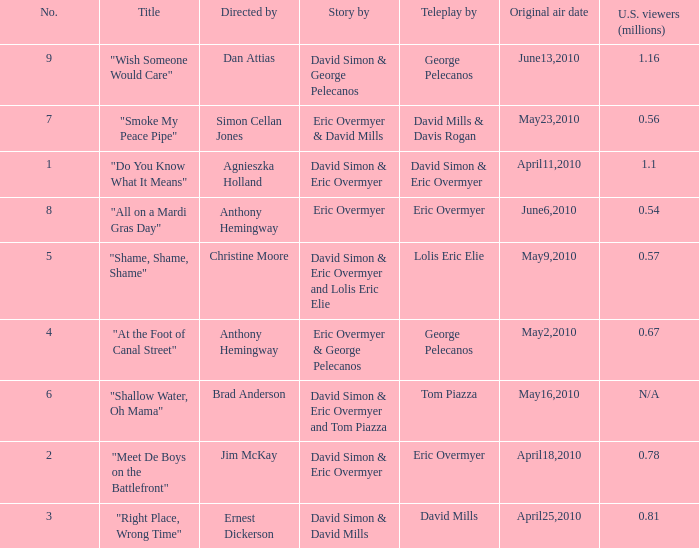Name the number for simon cellan jones 7.0. 